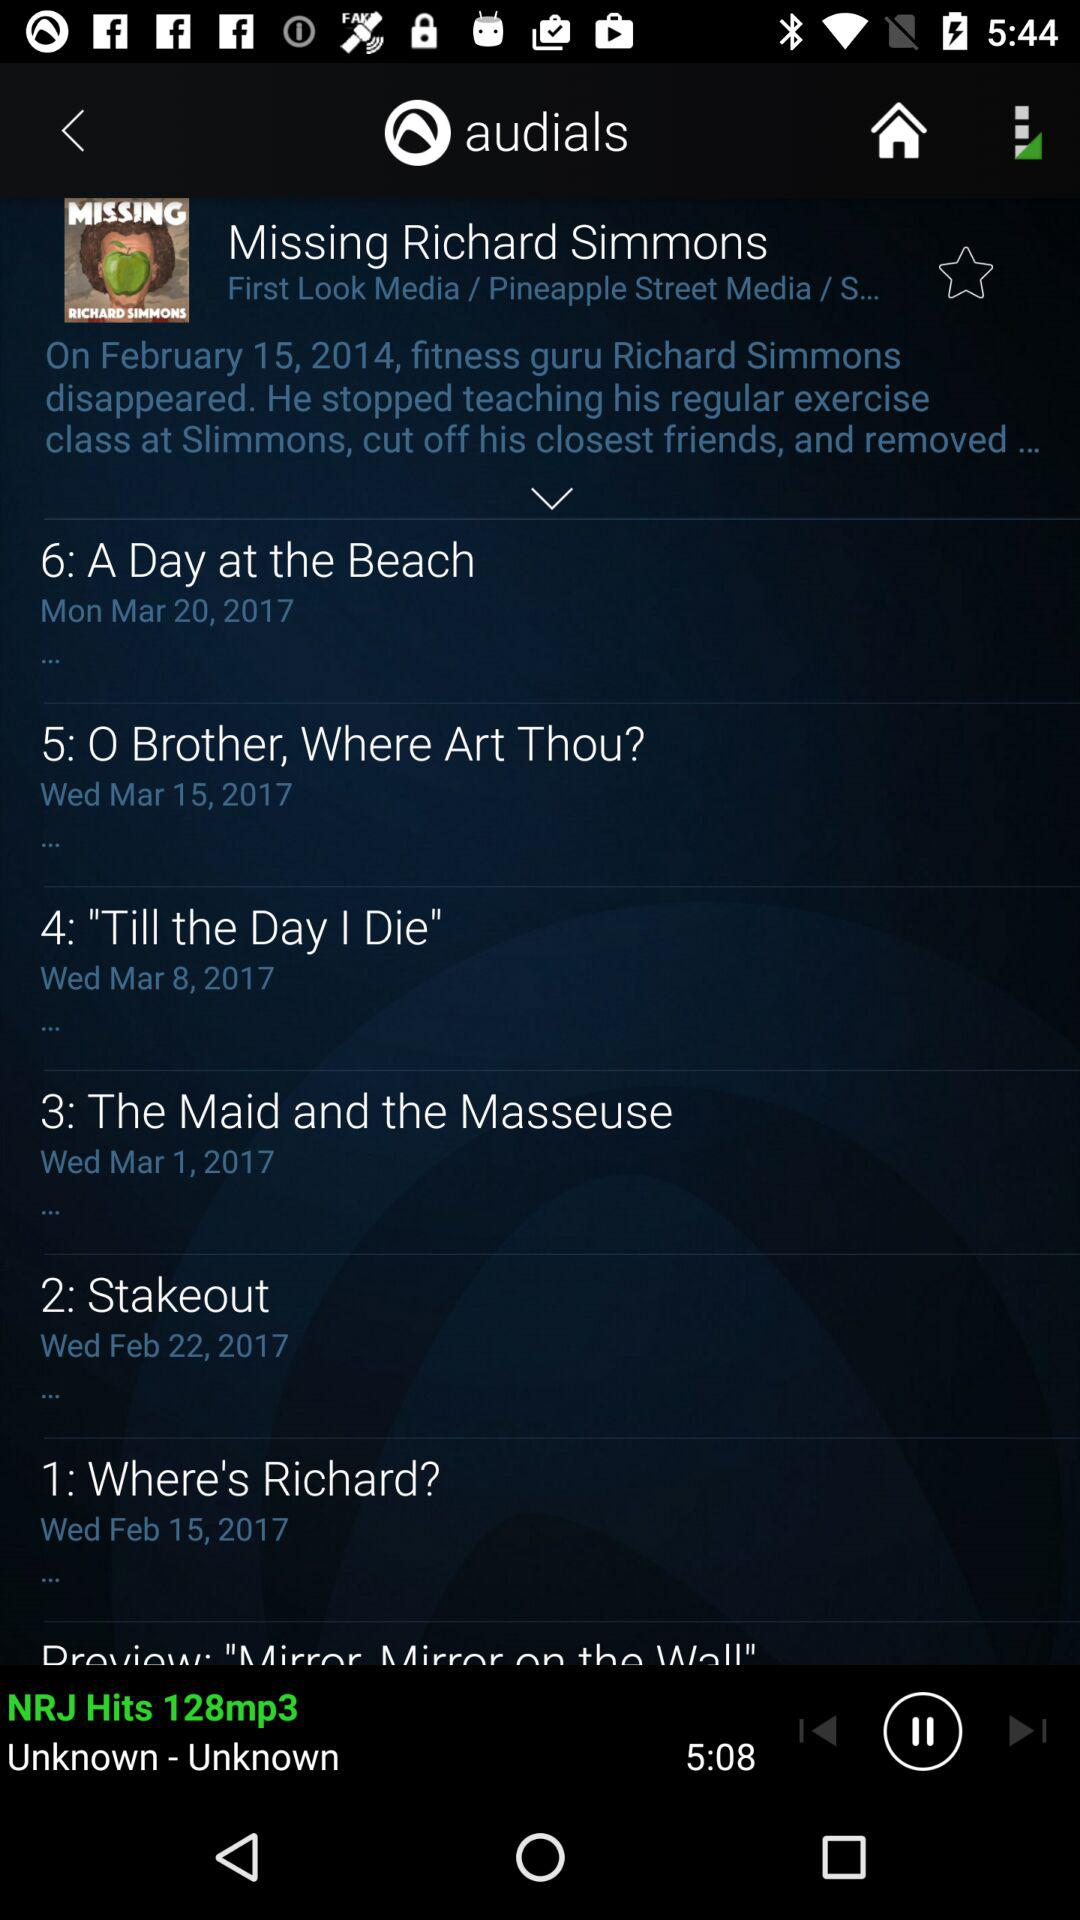What is the duration of "NRJ Hits"? The duration of "NRJ Hits" is 5 minutes 8 seconds. 